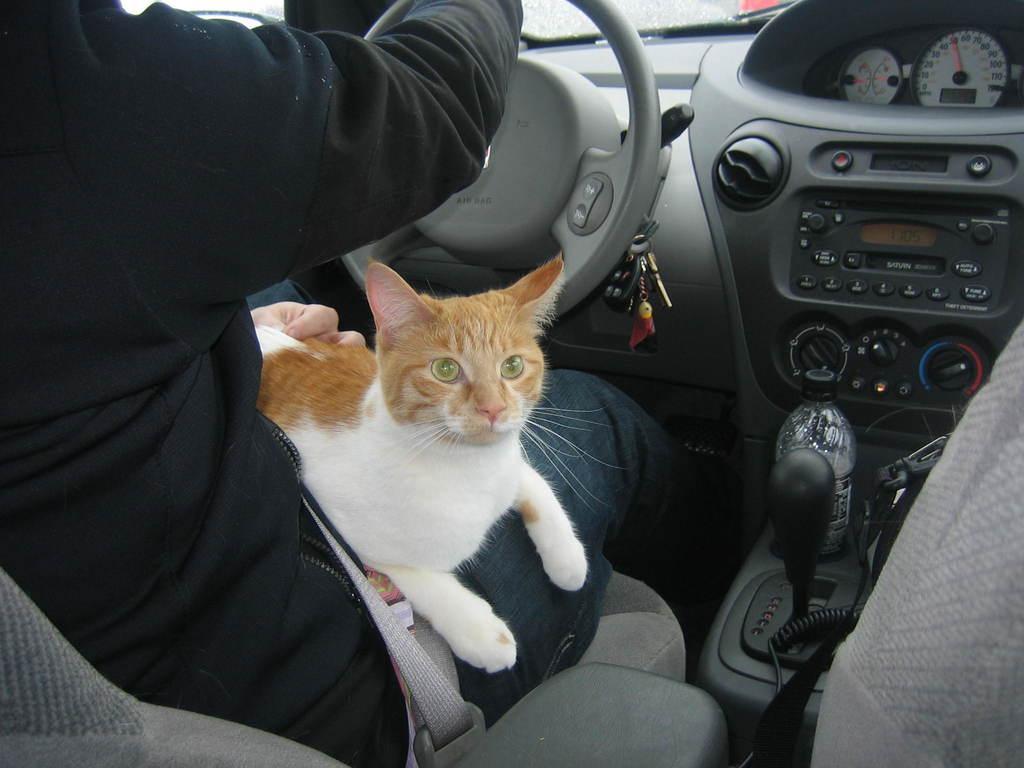Describe this image in one or two sentences. This picture is taken inside the car. In this image, on the left side, we can see a person sitting on the chair and, we can also see a cat is lying on the laps of a person. On the right side, we can also see a water bottle and a gear. In the background, we can see steering and key chain. 